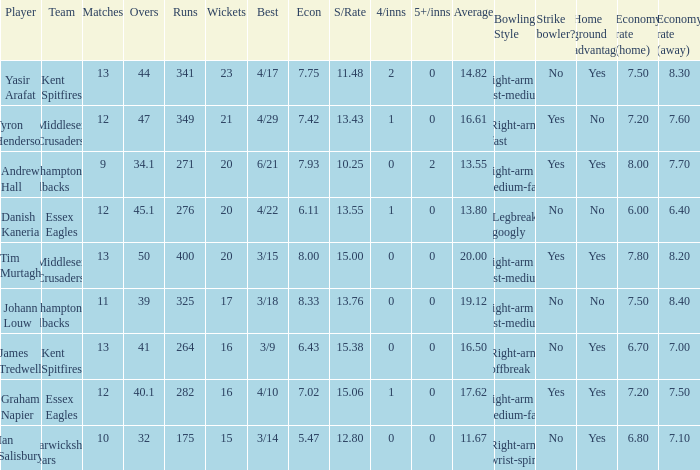Name the most 4/inns 2.0. 